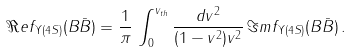Convert formula to latex. <formula><loc_0><loc_0><loc_500><loc_500>\Re e f _ { \Upsilon ( 4 S ) } ( B \bar { B } ) = \frac { 1 } { \pi } \, \int _ { 0 } ^ { v _ { t h } } \frac { d v ^ { 2 } } { ( 1 - v ^ { 2 } ) v ^ { 2 } } \, \Im m f _ { \Upsilon ( 4 S ) } ( B \bar { B } ) \, .</formula> 